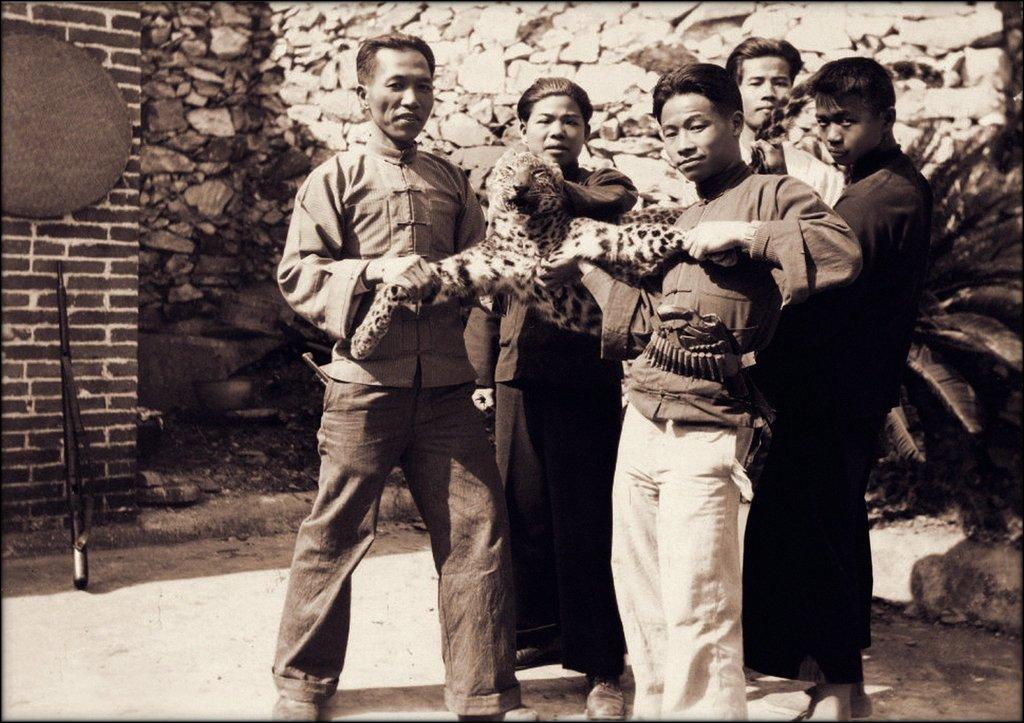What are the people in the image doing? The people are standing in the image and holding a cheetah. What is located on the left side of the image? There is a wall on the left side of the image. What type of natural elements can be seen in the image? There are rocks visible in the image. What is present on the right side of the image? There is a plant on the right side of the image. How many bodies are visible in the image? There are no bodies visible in the image, as the term "body" typically refers to a deceased person, and the image features people holding a cheetah. What type of tool is being used to fix the cheetah in the image? There is no tool visible in the image, and the cheetah is not being fixed; it is being held by the people. 